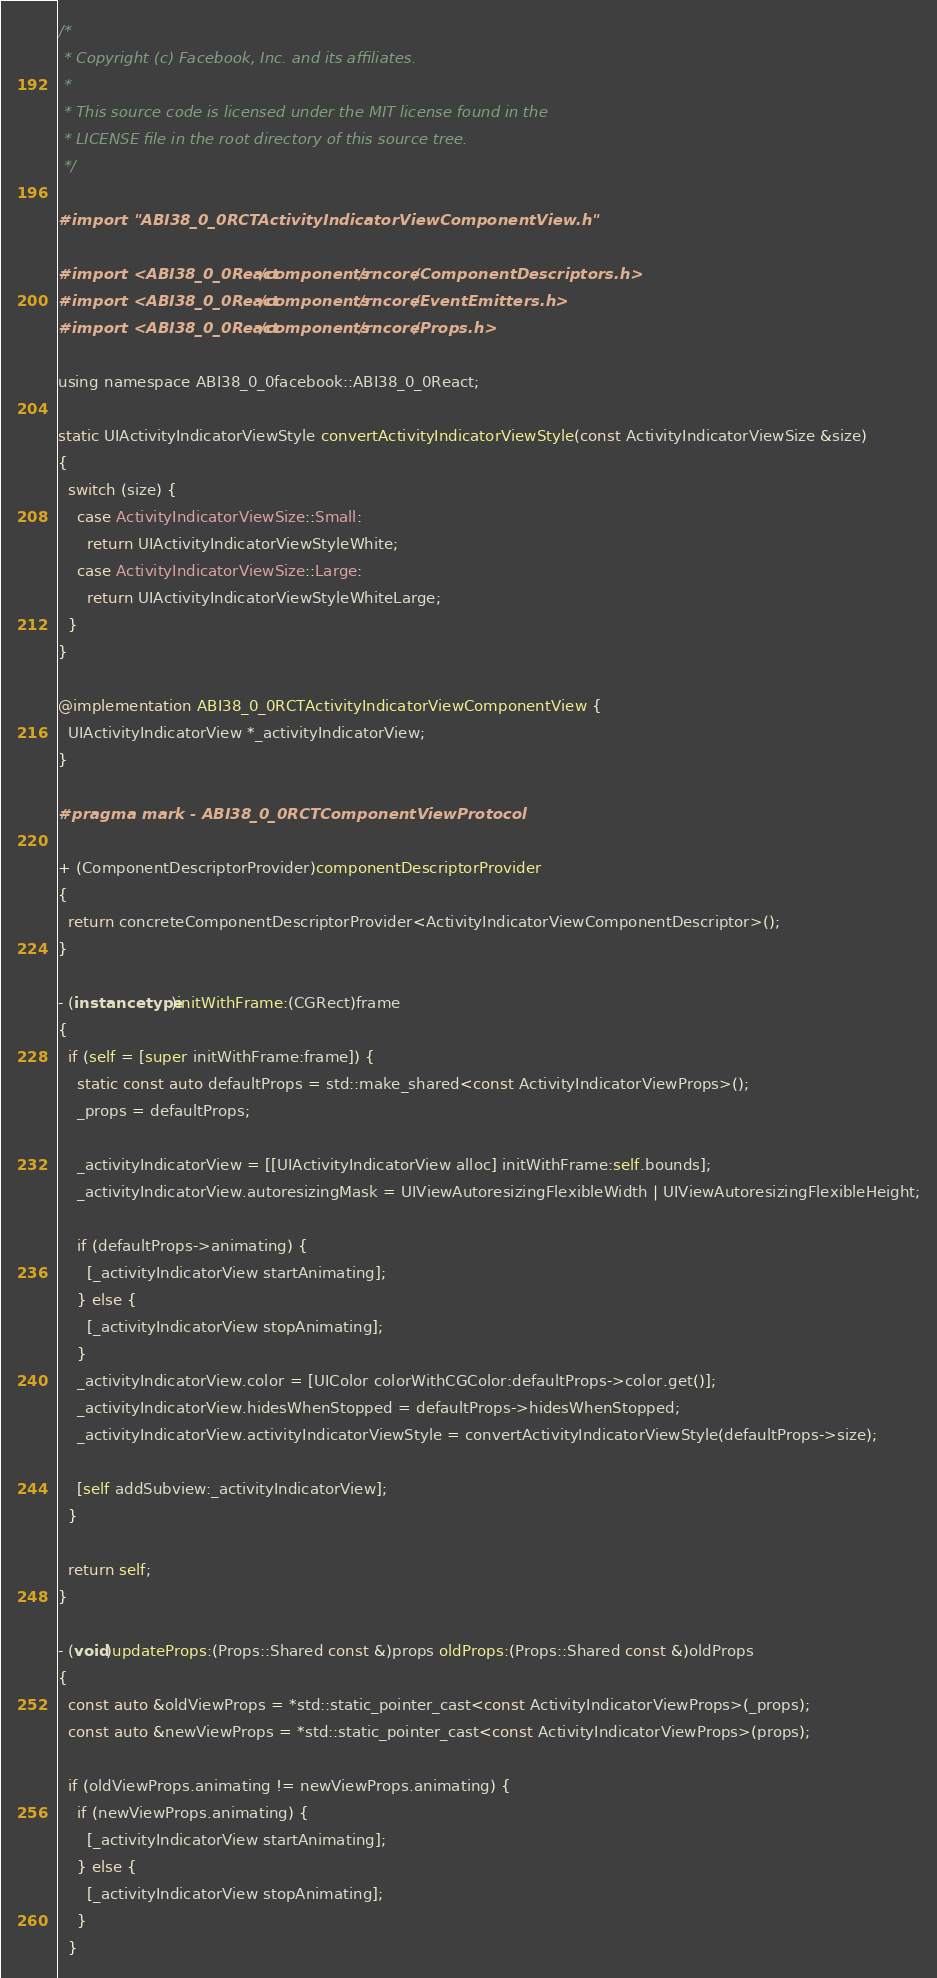Convert code to text. <code><loc_0><loc_0><loc_500><loc_500><_ObjectiveC_>/*
 * Copyright (c) Facebook, Inc. and its affiliates.
 *
 * This source code is licensed under the MIT license found in the
 * LICENSE file in the root directory of this source tree.
 */

#import "ABI38_0_0RCTActivityIndicatorViewComponentView.h"

#import <ABI38_0_0React/components/rncore/ComponentDescriptors.h>
#import <ABI38_0_0React/components/rncore/EventEmitters.h>
#import <ABI38_0_0React/components/rncore/Props.h>

using namespace ABI38_0_0facebook::ABI38_0_0React;

static UIActivityIndicatorViewStyle convertActivityIndicatorViewStyle(const ActivityIndicatorViewSize &size)
{
  switch (size) {
    case ActivityIndicatorViewSize::Small:
      return UIActivityIndicatorViewStyleWhite;
    case ActivityIndicatorViewSize::Large:
      return UIActivityIndicatorViewStyleWhiteLarge;
  }
}

@implementation ABI38_0_0RCTActivityIndicatorViewComponentView {
  UIActivityIndicatorView *_activityIndicatorView;
}

#pragma mark - ABI38_0_0RCTComponentViewProtocol

+ (ComponentDescriptorProvider)componentDescriptorProvider
{
  return concreteComponentDescriptorProvider<ActivityIndicatorViewComponentDescriptor>();
}

- (instancetype)initWithFrame:(CGRect)frame
{
  if (self = [super initWithFrame:frame]) {
    static const auto defaultProps = std::make_shared<const ActivityIndicatorViewProps>();
    _props = defaultProps;

    _activityIndicatorView = [[UIActivityIndicatorView alloc] initWithFrame:self.bounds];
    _activityIndicatorView.autoresizingMask = UIViewAutoresizingFlexibleWidth | UIViewAutoresizingFlexibleHeight;

    if (defaultProps->animating) {
      [_activityIndicatorView startAnimating];
    } else {
      [_activityIndicatorView stopAnimating];
    }
    _activityIndicatorView.color = [UIColor colorWithCGColor:defaultProps->color.get()];
    _activityIndicatorView.hidesWhenStopped = defaultProps->hidesWhenStopped;
    _activityIndicatorView.activityIndicatorViewStyle = convertActivityIndicatorViewStyle(defaultProps->size);

    [self addSubview:_activityIndicatorView];
  }

  return self;
}

- (void)updateProps:(Props::Shared const &)props oldProps:(Props::Shared const &)oldProps
{
  const auto &oldViewProps = *std::static_pointer_cast<const ActivityIndicatorViewProps>(_props);
  const auto &newViewProps = *std::static_pointer_cast<const ActivityIndicatorViewProps>(props);

  if (oldViewProps.animating != newViewProps.animating) {
    if (newViewProps.animating) {
      [_activityIndicatorView startAnimating];
    } else {
      [_activityIndicatorView stopAnimating];
    }
  }
</code> 